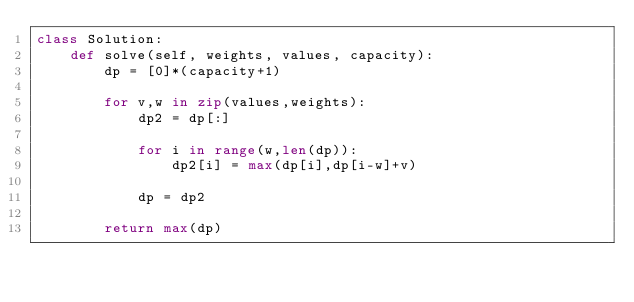<code> <loc_0><loc_0><loc_500><loc_500><_Python_>class Solution:
    def solve(self, weights, values, capacity):
        dp = [0]*(capacity+1)

        for v,w in zip(values,weights):
            dp2 = dp[:]

            for i in range(w,len(dp)):
                dp2[i] = max(dp[i],dp[i-w]+v)

            dp = dp2

        return max(dp)
</code> 